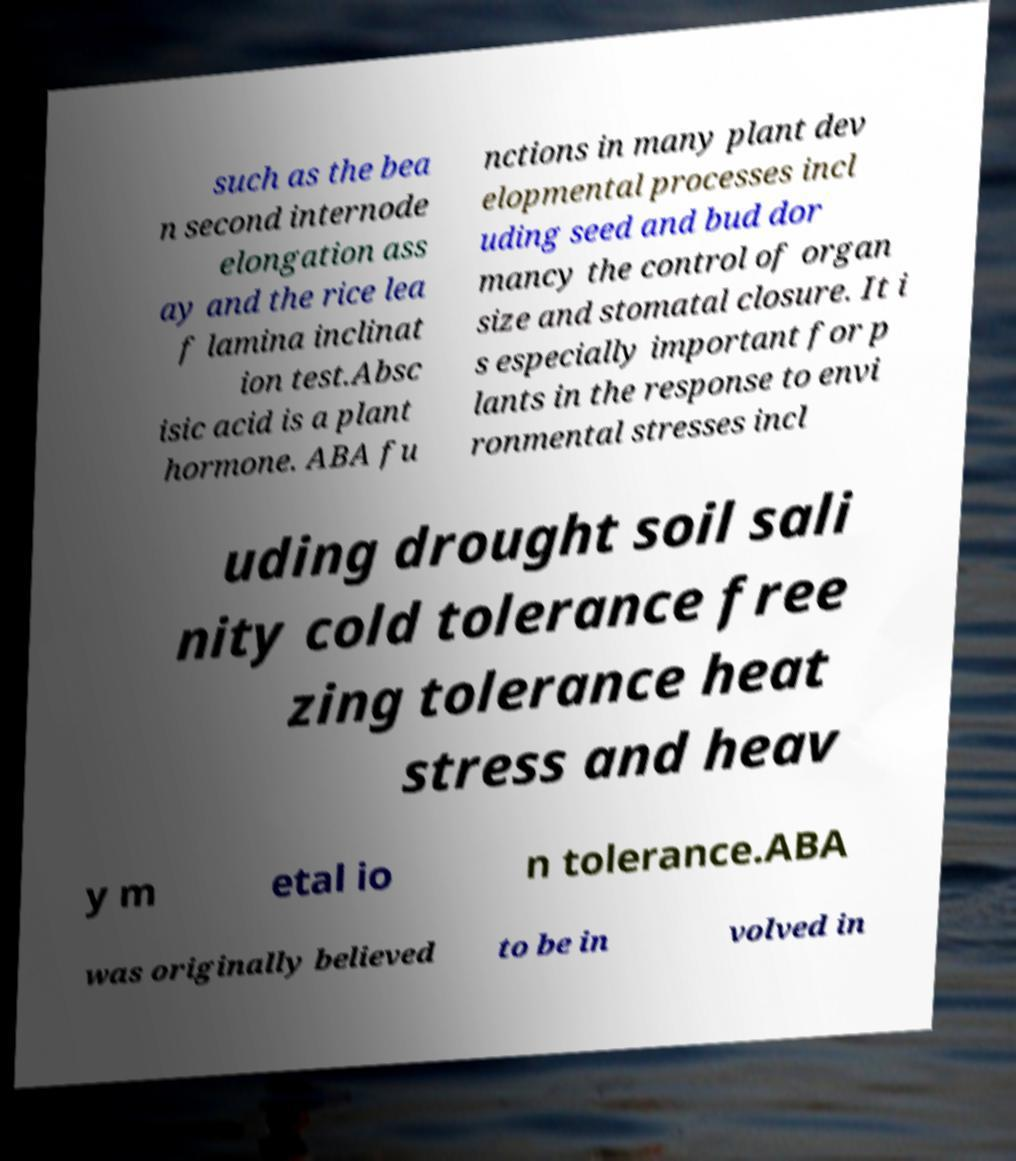Can you accurately transcribe the text from the provided image for me? such as the bea n second internode elongation ass ay and the rice lea f lamina inclinat ion test.Absc isic acid is a plant hormone. ABA fu nctions in many plant dev elopmental processes incl uding seed and bud dor mancy the control of organ size and stomatal closure. It i s especially important for p lants in the response to envi ronmental stresses incl uding drought soil sali nity cold tolerance free zing tolerance heat stress and heav y m etal io n tolerance.ABA was originally believed to be in volved in 